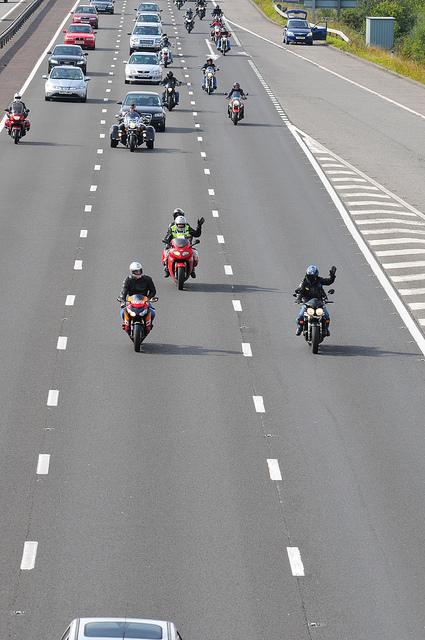How many people are in the picture?
Keep it brief. 10. Is this a one way road?
Quick response, please. Yes. How many vehicles are in this scene?
Be succinct. 26. Are there lines on the road to direct traffic?
Answer briefly. Yes. How many motorcycles are there?
Be succinct. 13. Is this a one-way road?
Give a very brief answer. Yes. 